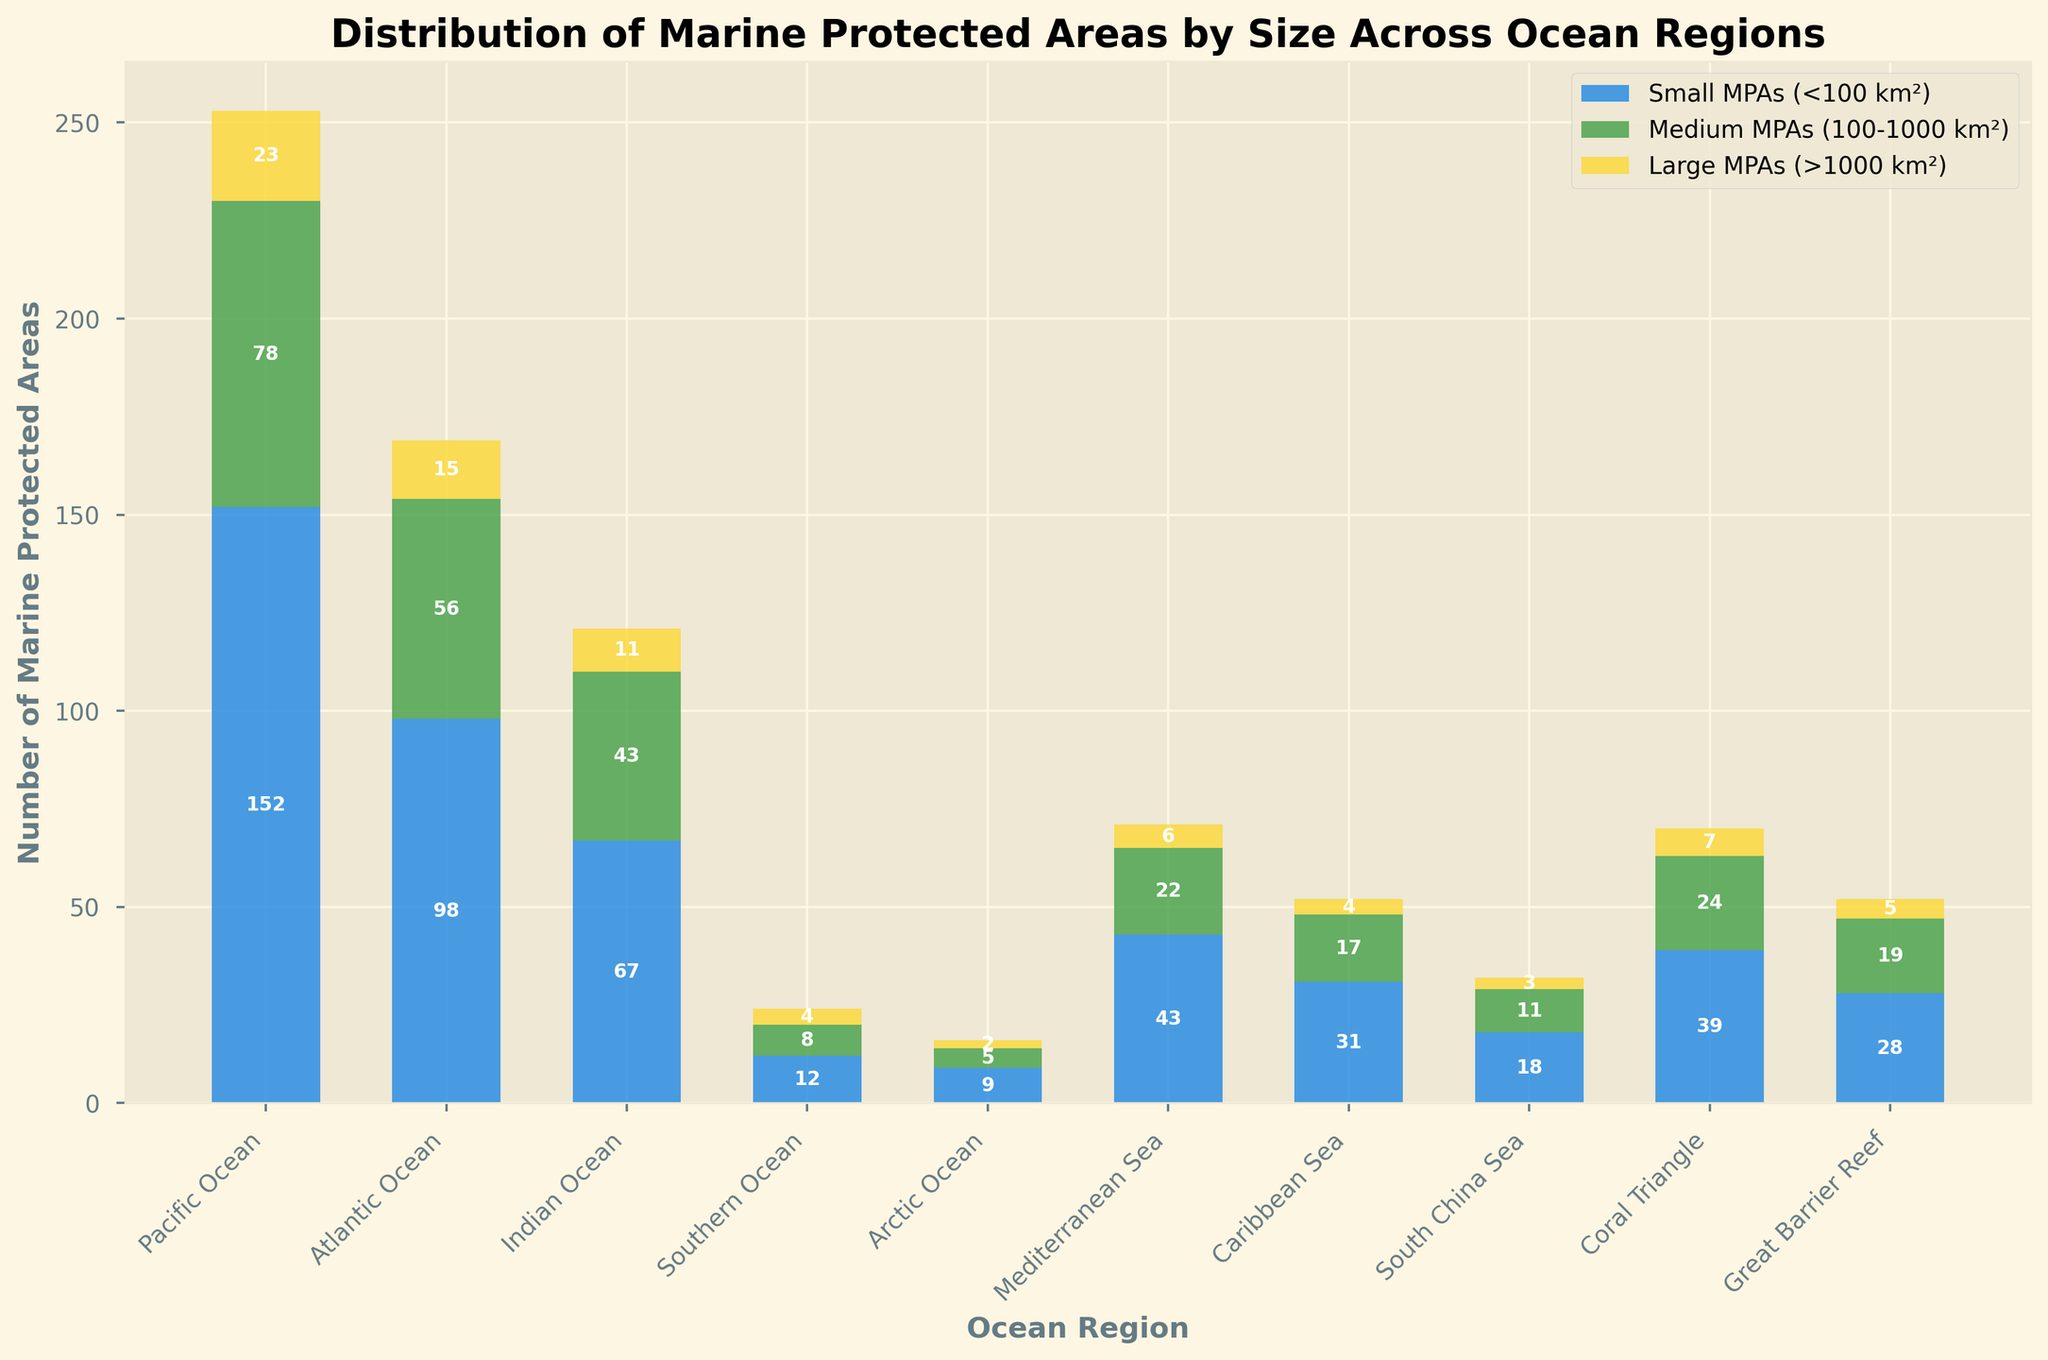Which ocean region has the largest number of small MPAs? To find this, look at the bar representing small MPAs for each ocean region. The Pacific Ocean has the highest bar for small MPAs.
Answer: Pacific Ocean How many large MPAs are there in the Atlantic Ocean? Check the height of the bar segment representing large MPAs for the Atlantic Ocean. The height shows 15.
Answer: 15 Which ocean region has more medium MPAs than small MPAs? Compare the heights of the bars representing small MPAs and medium MPAs for each ocean region. None of the ocean regions have more medium MPAs than small MPAs.
Answer: None What's the total number of MPAs in the Southern Ocean? Add the number of small, medium, and large MPAs in the Southern Ocean: 12 + 8 + 4 = 24.
Answer: 24 Compare the number of medium MPAs in the Indian Ocean to the number of small MPAs in the Mediterranean Sea. Which is greater? Check the bars for medium MPAs in the Indian Ocean and small MPAs in the Mediterranean Sea. The medium MPAs in the Indian Ocean are 43, and the small MPAs in the Mediterranean Sea are 43. Both are equal.
Answer: Equal What is the total number of MPAs in the Coral Triangle with any level of protection? Add the small, medium, and large MPAs in the Coral Triangle: 39 + 24 + 7 = 70.
Answer: 70 Which ocean region has the least number of total MPAs? Compare the total height of the stacked bars for each ocean region. The Arctic Ocean has the shortest total bar height.
Answer: Arctic Ocean How many more small MPAs does the Pacific Ocean have compared to the Caribbean Sea? Subtract the number of small MPAs in the Caribbean Sea from the small MPAs in the Pacific Ocean: 152 - 31 = 121.
Answer: 121 What's the difference in the number of fully protected MPAs between the Pacific Ocean and the Indian Ocean? Subtract the number of fully protected MPAs in the Indian Ocean from those in the Pacific Ocean: 45 - 22 = 23.
Answer: 23 